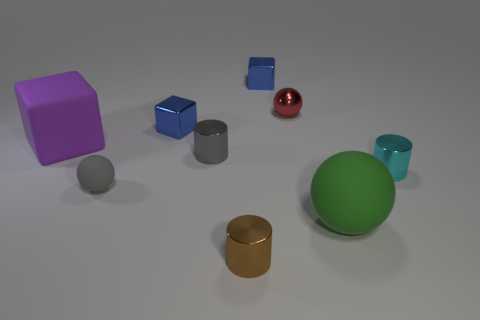What material is the cylinder that is the same color as the small matte object?
Provide a succinct answer. Metal. Is there another large object of the same shape as the brown object?
Make the answer very short. No. Does the gray object that is behind the tiny matte ball have the same material as the small sphere behind the big matte block?
Your response must be concise. Yes. There is a sphere that is behind the large thing left of the large green rubber ball that is in front of the tiny red metal ball; what size is it?
Your answer should be very brief. Small. There is a object that is the same size as the purple block; what is it made of?
Your answer should be very brief. Rubber. Is there a blue metal cylinder that has the same size as the green thing?
Provide a short and direct response. No. Does the cyan metal object have the same shape as the red thing?
Your answer should be very brief. No. There is a metallic cylinder on the left side of the tiny object in front of the gray matte object; are there any red metal balls that are right of it?
Ensure brevity in your answer.  Yes. What number of other things are there of the same color as the large matte block?
Make the answer very short. 0. There is a blue metal thing right of the gray metal cylinder; is its size the same as the blue cube that is on the left side of the gray metal cylinder?
Your answer should be very brief. Yes. 